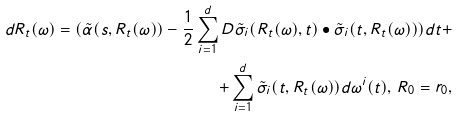<formula> <loc_0><loc_0><loc_500><loc_500>d R _ { t } ( \omega ) = ( \tilde { \alpha } ( s , R _ { t } ( \omega ) ) - \frac { 1 } { 2 } \sum _ { i = 1 } ^ { d } D \tilde { \sigma } _ { i } ( R _ { t } ( \omega ) , t ) \bullet \tilde { \sigma } _ { i } ( t , R _ { t } ( \omega ) ) ) d t + \\ + \sum _ { i = 1 } ^ { d } \tilde { \sigma } _ { i } ( t , R _ { t } ( \omega ) ) d \omega ^ { i } ( t ) , \, R _ { 0 } = r _ { 0 } ,</formula> 